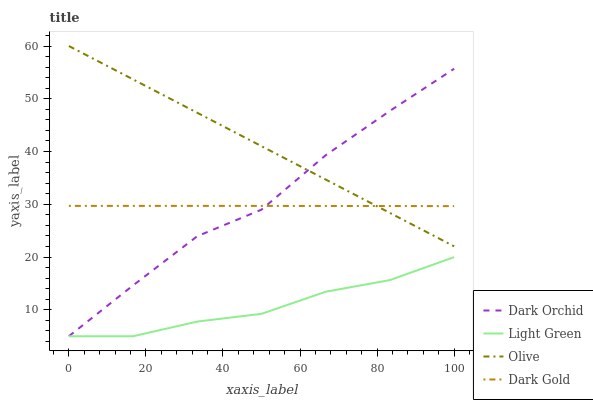Does Dark Orchid have the minimum area under the curve?
Answer yes or no. No. Does Dark Orchid have the maximum area under the curve?
Answer yes or no. No. Is Light Green the smoothest?
Answer yes or no. No. Is Light Green the roughest?
Answer yes or no. No. Does Dark Gold have the lowest value?
Answer yes or no. No. Does Dark Orchid have the highest value?
Answer yes or no. No. Is Light Green less than Olive?
Answer yes or no. Yes. Is Dark Gold greater than Light Green?
Answer yes or no. Yes. Does Light Green intersect Olive?
Answer yes or no. No. 